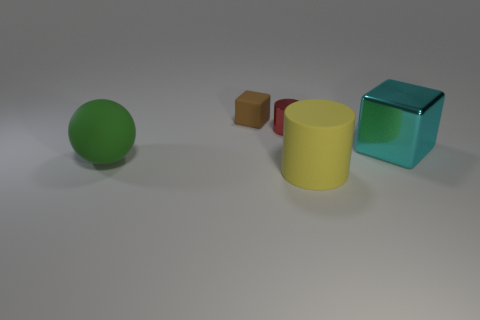Is the brown thing the same size as the yellow rubber thing?
Your response must be concise. No. Does the matte thing that is behind the small red cylinder have the same color as the metal block?
Your response must be concise. No. There is a cyan block; how many cubes are behind it?
Give a very brief answer. 1. Is the number of big metallic cubes greater than the number of big gray metal spheres?
Your response must be concise. Yes. What is the shape of the big thing that is both on the right side of the large green matte object and behind the yellow cylinder?
Offer a very short reply. Cube. Are any red metallic cylinders visible?
Make the answer very short. Yes. There is another object that is the same shape as the cyan thing; what is it made of?
Give a very brief answer. Rubber. There is a matte object that is on the right side of the small thing that is right of the tiny object that is left of the red cylinder; what is its shape?
Your answer should be compact. Cylinder. What number of other big things are the same shape as the yellow thing?
Offer a very short reply. 0. What material is the cylinder that is the same size as the brown thing?
Your answer should be very brief. Metal. 